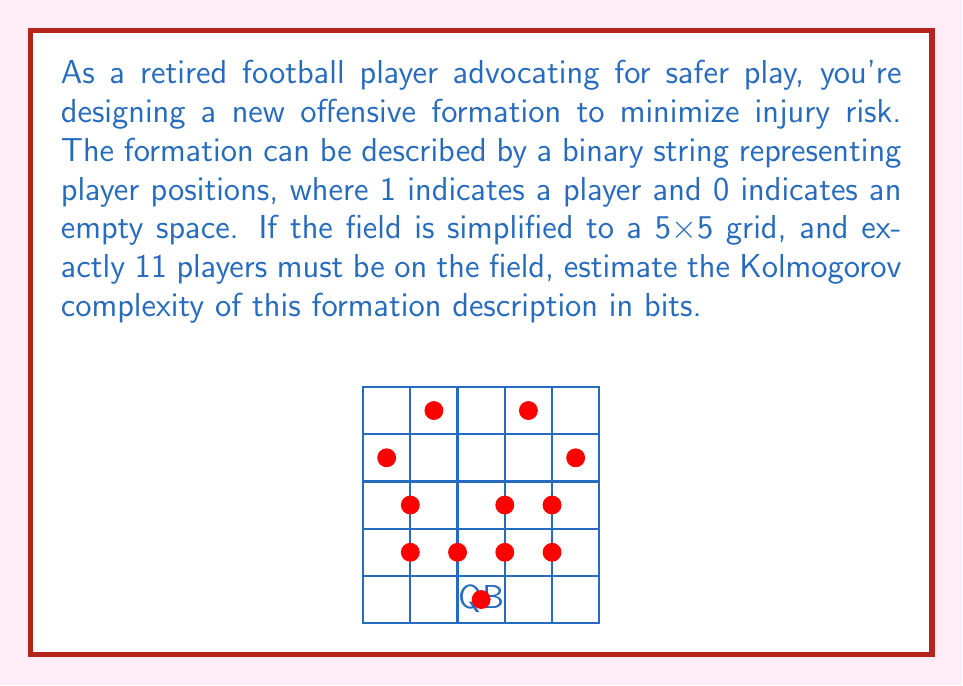Provide a solution to this math problem. To estimate the Kolmogorov complexity, we need to consider the minimum description length of the formation:

1) The field is represented by a 5x5 grid, which requires 25 bits to fully describe (one bit per position).

2) However, we know that exactly 11 players must be on the field. This constraint reduces the information needed to describe the formation.

3) We can use combinatorics to calculate the number of possible formations:
   $$\binom{25}{11} = \frac{25!}{11!(25-11)!} = 4,457,400$$

4) The Kolmogorov complexity is approximately the log2 of the number of possibilities:
   $$\log_2(4,457,400) \approx 22.09 \text{ bits}$$

5) We can round this up to 23 bits, as we need a whole number of bits to encode the information.

6) This is significantly less than the 25 bits needed to describe each position individually, demonstrating that the constraint of exactly 11 players reduces the complexity.

7) The actual Kolmogorov complexity might be slightly lower if there's a more efficient way to describe the formation, but this estimate provides a reasonable upper bound.
Answer: 23 bits 